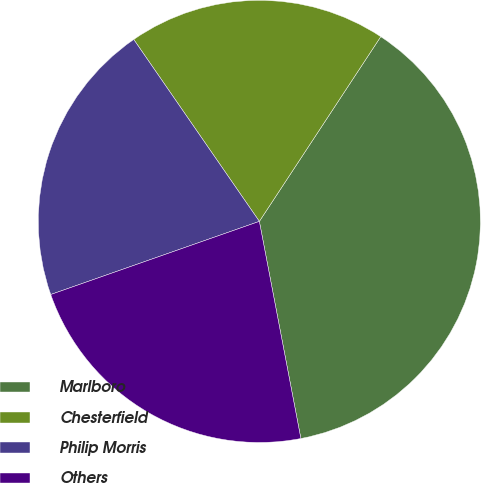Convert chart to OTSL. <chart><loc_0><loc_0><loc_500><loc_500><pie_chart><fcel>Marlboro<fcel>Chesterfield<fcel>Philip Morris<fcel>Others<nl><fcel>37.74%<fcel>18.87%<fcel>20.75%<fcel>22.64%<nl></chart> 